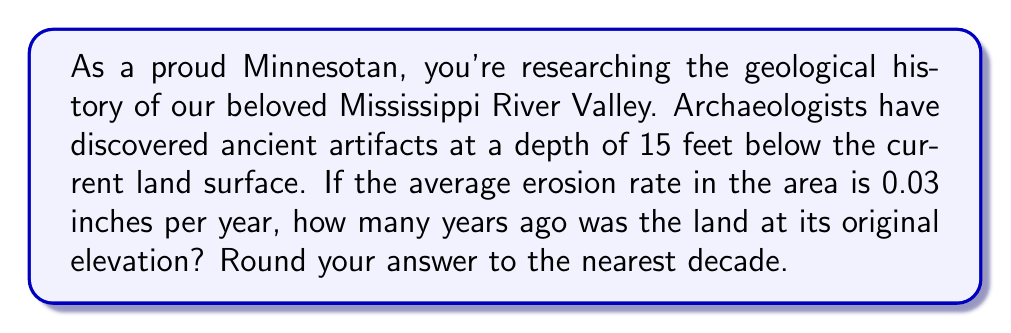Help me with this question. Let's approach this step-by-step:

1) First, we need to convert all measurements to the same unit. Let's use inches:
   15 feet = 15 × 12 = 180 inches

2) Now, we can set up an equation:
   $$ \text{Depth} = \text{Erosion Rate} \times \text{Time} $$

3) Plugging in our known values:
   $$ 180 \text{ inches} = 0.03 \text{ inches/year} \times t \text{ years} $$

4) To solve for t, we divide both sides by 0.03:
   $$ t = \frac{180}{0.03} = 6000 \text{ years} $$

5) The question asks to round to the nearest decade, which is already done as 6000 is divisible by 10.

This calculation tells us that the land was at its original elevation 6000 years ago, giving us a fascinating glimpse into the ancient history of our Mississippi River Valley!
Answer: 6000 years 